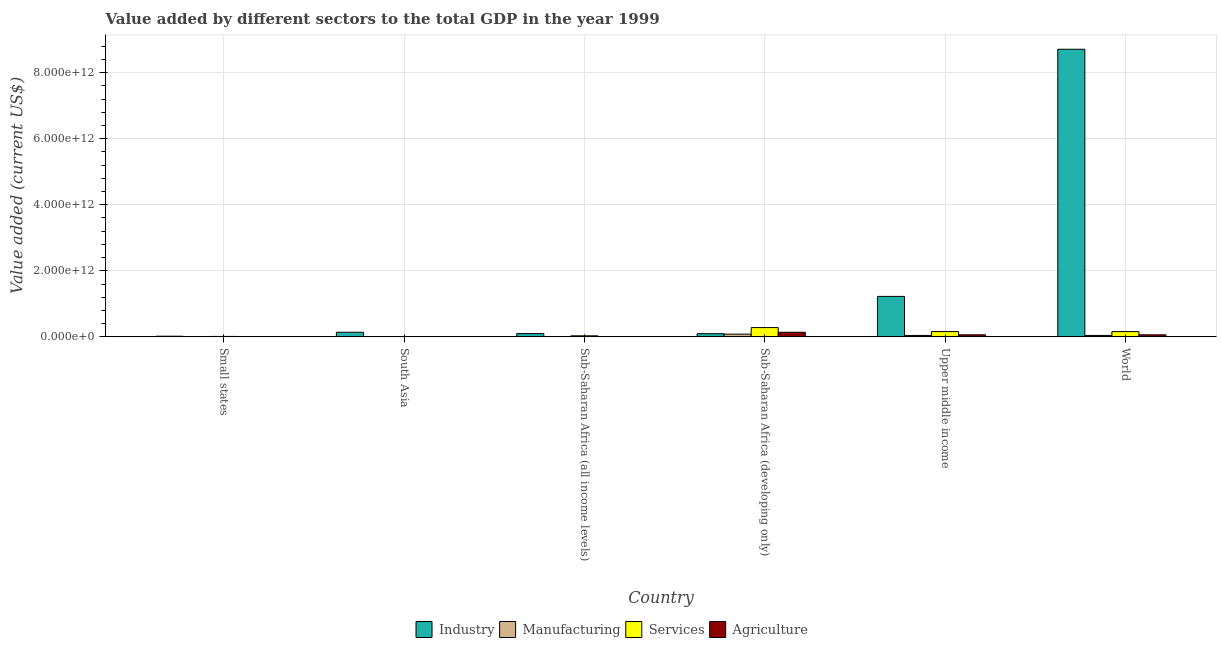How many different coloured bars are there?
Make the answer very short. 4. How many groups of bars are there?
Make the answer very short. 6. Are the number of bars per tick equal to the number of legend labels?
Your answer should be very brief. Yes. How many bars are there on the 6th tick from the left?
Your answer should be compact. 4. How many bars are there on the 6th tick from the right?
Provide a short and direct response. 4. What is the label of the 1st group of bars from the left?
Keep it short and to the point. Small states. What is the value added by industrial sector in South Asia?
Your response must be concise. 1.39e+11. Across all countries, what is the maximum value added by manufacturing sector?
Provide a succinct answer. 8.26e+1. Across all countries, what is the minimum value added by manufacturing sector?
Give a very brief answer. 3.54e+08. In which country was the value added by agricultural sector maximum?
Your answer should be very brief. Sub-Saharan Africa (developing only). In which country was the value added by services sector minimum?
Ensure brevity in your answer.  South Asia. What is the total value added by agricultural sector in the graph?
Your response must be concise. 2.71e+11. What is the difference between the value added by agricultural sector in Small states and that in South Asia?
Your answer should be very brief. 1.72e+09. What is the difference between the value added by services sector in Upper middle income and the value added by industrial sector in South Asia?
Ensure brevity in your answer.  2.04e+1. What is the average value added by industrial sector per country?
Make the answer very short. 1.72e+12. What is the difference between the value added by industrial sector and value added by services sector in Small states?
Your answer should be very brief. 6.79e+09. In how many countries, is the value added by industrial sector greater than 5200000000000 US$?
Provide a short and direct response. 1. What is the ratio of the value added by agricultural sector in Sub-Saharan Africa (all income levels) to that in Sub-Saharan Africa (developing only)?
Your answer should be very brief. 0.03. What is the difference between the highest and the second highest value added by manufacturing sector?
Offer a very short reply. 3.92e+1. What is the difference between the highest and the lowest value added by agricultural sector?
Provide a short and direct response. 1.38e+11. In how many countries, is the value added by industrial sector greater than the average value added by industrial sector taken over all countries?
Ensure brevity in your answer.  1. Is the sum of the value added by industrial sector in Small states and Sub-Saharan Africa (developing only) greater than the maximum value added by services sector across all countries?
Keep it short and to the point. No. Is it the case that in every country, the sum of the value added by agricultural sector and value added by services sector is greater than the sum of value added by industrial sector and value added by manufacturing sector?
Provide a succinct answer. No. What does the 2nd bar from the left in Small states represents?
Provide a short and direct response. Manufacturing. What does the 4th bar from the right in Sub-Saharan Africa (all income levels) represents?
Offer a terse response. Industry. How many bars are there?
Provide a short and direct response. 24. How many countries are there in the graph?
Offer a terse response. 6. What is the difference between two consecutive major ticks on the Y-axis?
Give a very brief answer. 2.00e+12. Are the values on the major ticks of Y-axis written in scientific E-notation?
Ensure brevity in your answer.  Yes. Does the graph contain grids?
Provide a short and direct response. Yes. How many legend labels are there?
Your response must be concise. 4. What is the title of the graph?
Offer a very short reply. Value added by different sectors to the total GDP in the year 1999. Does "Others" appear as one of the legend labels in the graph?
Offer a very short reply. No. What is the label or title of the Y-axis?
Ensure brevity in your answer.  Value added (current US$). What is the Value added (current US$) in Industry in Small states?
Your answer should be very brief. 2.01e+1. What is the Value added (current US$) of Manufacturing in Small states?
Ensure brevity in your answer.  3.18e+09. What is the Value added (current US$) of Services in Small states?
Your response must be concise. 1.33e+1. What is the Value added (current US$) in Agriculture in Small states?
Offer a very short reply. 2.44e+09. What is the Value added (current US$) of Industry in South Asia?
Give a very brief answer. 1.39e+11. What is the Value added (current US$) in Manufacturing in South Asia?
Ensure brevity in your answer.  3.54e+08. What is the Value added (current US$) of Services in South Asia?
Offer a very short reply. 1.94e+09. What is the Value added (current US$) in Agriculture in South Asia?
Your answer should be very brief. 7.24e+08. What is the Value added (current US$) of Industry in Sub-Saharan Africa (all income levels)?
Offer a very short reply. 9.94e+1. What is the Value added (current US$) in Manufacturing in Sub-Saharan Africa (all income levels)?
Your answer should be very brief. 5.74e+09. What is the Value added (current US$) in Services in Sub-Saharan Africa (all income levels)?
Offer a very short reply. 3.25e+1. What is the Value added (current US$) of Agriculture in Sub-Saharan Africa (all income levels)?
Offer a very short reply. 4.70e+09. What is the Value added (current US$) in Industry in Sub-Saharan Africa (developing only)?
Provide a short and direct response. 9.56e+1. What is the Value added (current US$) of Manufacturing in Sub-Saharan Africa (developing only)?
Give a very brief answer. 8.26e+1. What is the Value added (current US$) in Services in Sub-Saharan Africa (developing only)?
Give a very brief answer. 2.81e+11. What is the Value added (current US$) in Agriculture in Sub-Saharan Africa (developing only)?
Provide a short and direct response. 1.39e+11. What is the Value added (current US$) in Industry in Upper middle income?
Keep it short and to the point. 1.23e+12. What is the Value added (current US$) of Manufacturing in Upper middle income?
Provide a succinct answer. 4.34e+1. What is the Value added (current US$) in Services in Upper middle income?
Your answer should be very brief. 1.60e+11. What is the Value added (current US$) in Agriculture in Upper middle income?
Offer a terse response. 6.19e+1. What is the Value added (current US$) in Industry in World?
Give a very brief answer. 8.71e+12. What is the Value added (current US$) of Manufacturing in World?
Your response must be concise. 4.30e+1. What is the Value added (current US$) in Services in World?
Your answer should be very brief. 1.59e+11. What is the Value added (current US$) of Agriculture in World?
Offer a very short reply. 6.18e+1. Across all countries, what is the maximum Value added (current US$) in Industry?
Offer a very short reply. 8.71e+12. Across all countries, what is the maximum Value added (current US$) of Manufacturing?
Offer a very short reply. 8.26e+1. Across all countries, what is the maximum Value added (current US$) of Services?
Your answer should be compact. 2.81e+11. Across all countries, what is the maximum Value added (current US$) of Agriculture?
Your answer should be very brief. 1.39e+11. Across all countries, what is the minimum Value added (current US$) of Industry?
Your response must be concise. 2.01e+1. Across all countries, what is the minimum Value added (current US$) in Manufacturing?
Keep it short and to the point. 3.54e+08. Across all countries, what is the minimum Value added (current US$) of Services?
Ensure brevity in your answer.  1.94e+09. Across all countries, what is the minimum Value added (current US$) of Agriculture?
Provide a succinct answer. 7.24e+08. What is the total Value added (current US$) of Industry in the graph?
Your answer should be very brief. 1.03e+13. What is the total Value added (current US$) of Manufacturing in the graph?
Your answer should be compact. 1.78e+11. What is the total Value added (current US$) of Services in the graph?
Provide a succinct answer. 6.48e+11. What is the total Value added (current US$) in Agriculture in the graph?
Offer a very short reply. 2.71e+11. What is the difference between the Value added (current US$) in Industry in Small states and that in South Asia?
Make the answer very short. -1.19e+11. What is the difference between the Value added (current US$) in Manufacturing in Small states and that in South Asia?
Your response must be concise. 2.83e+09. What is the difference between the Value added (current US$) of Services in Small states and that in South Asia?
Offer a terse response. 1.13e+1. What is the difference between the Value added (current US$) of Agriculture in Small states and that in South Asia?
Give a very brief answer. 1.72e+09. What is the difference between the Value added (current US$) of Industry in Small states and that in Sub-Saharan Africa (all income levels)?
Make the answer very short. -7.94e+1. What is the difference between the Value added (current US$) of Manufacturing in Small states and that in Sub-Saharan Africa (all income levels)?
Provide a succinct answer. -2.55e+09. What is the difference between the Value added (current US$) in Services in Small states and that in Sub-Saharan Africa (all income levels)?
Ensure brevity in your answer.  -1.92e+1. What is the difference between the Value added (current US$) of Agriculture in Small states and that in Sub-Saharan Africa (all income levels)?
Provide a succinct answer. -2.26e+09. What is the difference between the Value added (current US$) of Industry in Small states and that in Sub-Saharan Africa (developing only)?
Make the answer very short. -7.56e+1. What is the difference between the Value added (current US$) in Manufacturing in Small states and that in Sub-Saharan Africa (developing only)?
Keep it short and to the point. -7.94e+1. What is the difference between the Value added (current US$) of Services in Small states and that in Sub-Saharan Africa (developing only)?
Provide a succinct answer. -2.68e+11. What is the difference between the Value added (current US$) in Agriculture in Small states and that in Sub-Saharan Africa (developing only)?
Your answer should be compact. -1.37e+11. What is the difference between the Value added (current US$) in Industry in Small states and that in Upper middle income?
Offer a terse response. -1.21e+12. What is the difference between the Value added (current US$) in Manufacturing in Small states and that in Upper middle income?
Give a very brief answer. -4.02e+1. What is the difference between the Value added (current US$) in Services in Small states and that in Upper middle income?
Give a very brief answer. -1.47e+11. What is the difference between the Value added (current US$) in Agriculture in Small states and that in Upper middle income?
Offer a terse response. -5.95e+1. What is the difference between the Value added (current US$) of Industry in Small states and that in World?
Give a very brief answer. -8.69e+12. What is the difference between the Value added (current US$) of Manufacturing in Small states and that in World?
Offer a very short reply. -3.98e+1. What is the difference between the Value added (current US$) of Services in Small states and that in World?
Offer a terse response. -1.46e+11. What is the difference between the Value added (current US$) in Agriculture in Small states and that in World?
Give a very brief answer. -5.94e+1. What is the difference between the Value added (current US$) in Industry in South Asia and that in Sub-Saharan Africa (all income levels)?
Offer a terse response. 4.01e+1. What is the difference between the Value added (current US$) in Manufacturing in South Asia and that in Sub-Saharan Africa (all income levels)?
Provide a short and direct response. -5.38e+09. What is the difference between the Value added (current US$) of Services in South Asia and that in Sub-Saharan Africa (all income levels)?
Keep it short and to the point. -3.06e+1. What is the difference between the Value added (current US$) in Agriculture in South Asia and that in Sub-Saharan Africa (all income levels)?
Your answer should be compact. -3.98e+09. What is the difference between the Value added (current US$) in Industry in South Asia and that in Sub-Saharan Africa (developing only)?
Offer a terse response. 4.38e+1. What is the difference between the Value added (current US$) in Manufacturing in South Asia and that in Sub-Saharan Africa (developing only)?
Your answer should be very brief. -8.22e+1. What is the difference between the Value added (current US$) in Services in South Asia and that in Sub-Saharan Africa (developing only)?
Your response must be concise. -2.79e+11. What is the difference between the Value added (current US$) of Agriculture in South Asia and that in Sub-Saharan Africa (developing only)?
Ensure brevity in your answer.  -1.38e+11. What is the difference between the Value added (current US$) in Industry in South Asia and that in Upper middle income?
Provide a short and direct response. -1.09e+12. What is the difference between the Value added (current US$) in Manufacturing in South Asia and that in Upper middle income?
Offer a very short reply. -4.30e+1. What is the difference between the Value added (current US$) of Services in South Asia and that in Upper middle income?
Offer a terse response. -1.58e+11. What is the difference between the Value added (current US$) in Agriculture in South Asia and that in Upper middle income?
Give a very brief answer. -6.12e+1. What is the difference between the Value added (current US$) of Industry in South Asia and that in World?
Make the answer very short. -8.57e+12. What is the difference between the Value added (current US$) in Manufacturing in South Asia and that in World?
Offer a terse response. -4.26e+1. What is the difference between the Value added (current US$) of Services in South Asia and that in World?
Your response must be concise. -1.57e+11. What is the difference between the Value added (current US$) in Agriculture in South Asia and that in World?
Keep it short and to the point. -6.11e+1. What is the difference between the Value added (current US$) of Industry in Sub-Saharan Africa (all income levels) and that in Sub-Saharan Africa (developing only)?
Offer a terse response. 3.78e+09. What is the difference between the Value added (current US$) in Manufacturing in Sub-Saharan Africa (all income levels) and that in Sub-Saharan Africa (developing only)?
Keep it short and to the point. -7.68e+1. What is the difference between the Value added (current US$) of Services in Sub-Saharan Africa (all income levels) and that in Sub-Saharan Africa (developing only)?
Your response must be concise. -2.49e+11. What is the difference between the Value added (current US$) of Agriculture in Sub-Saharan Africa (all income levels) and that in Sub-Saharan Africa (developing only)?
Ensure brevity in your answer.  -1.34e+11. What is the difference between the Value added (current US$) of Industry in Sub-Saharan Africa (all income levels) and that in Upper middle income?
Your answer should be very brief. -1.13e+12. What is the difference between the Value added (current US$) in Manufacturing in Sub-Saharan Africa (all income levels) and that in Upper middle income?
Ensure brevity in your answer.  -3.76e+1. What is the difference between the Value added (current US$) of Services in Sub-Saharan Africa (all income levels) and that in Upper middle income?
Ensure brevity in your answer.  -1.27e+11. What is the difference between the Value added (current US$) in Agriculture in Sub-Saharan Africa (all income levels) and that in Upper middle income?
Provide a short and direct response. -5.72e+1. What is the difference between the Value added (current US$) of Industry in Sub-Saharan Africa (all income levels) and that in World?
Give a very brief answer. -8.61e+12. What is the difference between the Value added (current US$) of Manufacturing in Sub-Saharan Africa (all income levels) and that in World?
Provide a short and direct response. -3.72e+1. What is the difference between the Value added (current US$) of Services in Sub-Saharan Africa (all income levels) and that in World?
Make the answer very short. -1.27e+11. What is the difference between the Value added (current US$) in Agriculture in Sub-Saharan Africa (all income levels) and that in World?
Your answer should be very brief. -5.71e+1. What is the difference between the Value added (current US$) in Industry in Sub-Saharan Africa (developing only) and that in Upper middle income?
Provide a succinct answer. -1.13e+12. What is the difference between the Value added (current US$) in Manufacturing in Sub-Saharan Africa (developing only) and that in Upper middle income?
Provide a succinct answer. 3.92e+1. What is the difference between the Value added (current US$) of Services in Sub-Saharan Africa (developing only) and that in Upper middle income?
Give a very brief answer. 1.21e+11. What is the difference between the Value added (current US$) in Agriculture in Sub-Saharan Africa (developing only) and that in Upper middle income?
Keep it short and to the point. 7.72e+1. What is the difference between the Value added (current US$) of Industry in Sub-Saharan Africa (developing only) and that in World?
Give a very brief answer. -8.61e+12. What is the difference between the Value added (current US$) in Manufacturing in Sub-Saharan Africa (developing only) and that in World?
Provide a short and direct response. 3.96e+1. What is the difference between the Value added (current US$) of Services in Sub-Saharan Africa (developing only) and that in World?
Keep it short and to the point. 1.22e+11. What is the difference between the Value added (current US$) in Agriculture in Sub-Saharan Africa (developing only) and that in World?
Give a very brief answer. 7.74e+1. What is the difference between the Value added (current US$) in Industry in Upper middle income and that in World?
Give a very brief answer. -7.48e+12. What is the difference between the Value added (current US$) in Manufacturing in Upper middle income and that in World?
Make the answer very short. 4.04e+08. What is the difference between the Value added (current US$) in Services in Upper middle income and that in World?
Your answer should be compact. 5.71e+08. What is the difference between the Value added (current US$) of Agriculture in Upper middle income and that in World?
Your response must be concise. 1.41e+08. What is the difference between the Value added (current US$) in Industry in Small states and the Value added (current US$) in Manufacturing in South Asia?
Offer a terse response. 1.97e+1. What is the difference between the Value added (current US$) in Industry in Small states and the Value added (current US$) in Services in South Asia?
Provide a short and direct response. 1.81e+1. What is the difference between the Value added (current US$) in Industry in Small states and the Value added (current US$) in Agriculture in South Asia?
Your answer should be very brief. 1.93e+1. What is the difference between the Value added (current US$) in Manufacturing in Small states and the Value added (current US$) in Services in South Asia?
Offer a terse response. 1.25e+09. What is the difference between the Value added (current US$) of Manufacturing in Small states and the Value added (current US$) of Agriculture in South Asia?
Your answer should be compact. 2.46e+09. What is the difference between the Value added (current US$) in Services in Small states and the Value added (current US$) in Agriculture in South Asia?
Keep it short and to the point. 1.25e+1. What is the difference between the Value added (current US$) of Industry in Small states and the Value added (current US$) of Manufacturing in Sub-Saharan Africa (all income levels)?
Keep it short and to the point. 1.43e+1. What is the difference between the Value added (current US$) of Industry in Small states and the Value added (current US$) of Services in Sub-Saharan Africa (all income levels)?
Provide a short and direct response. -1.24e+1. What is the difference between the Value added (current US$) of Industry in Small states and the Value added (current US$) of Agriculture in Sub-Saharan Africa (all income levels)?
Make the answer very short. 1.54e+1. What is the difference between the Value added (current US$) of Manufacturing in Small states and the Value added (current US$) of Services in Sub-Saharan Africa (all income levels)?
Give a very brief answer. -2.93e+1. What is the difference between the Value added (current US$) in Manufacturing in Small states and the Value added (current US$) in Agriculture in Sub-Saharan Africa (all income levels)?
Your answer should be compact. -1.52e+09. What is the difference between the Value added (current US$) of Services in Small states and the Value added (current US$) of Agriculture in Sub-Saharan Africa (all income levels)?
Your answer should be compact. 8.56e+09. What is the difference between the Value added (current US$) of Industry in Small states and the Value added (current US$) of Manufacturing in Sub-Saharan Africa (developing only)?
Provide a succinct answer. -6.25e+1. What is the difference between the Value added (current US$) in Industry in Small states and the Value added (current US$) in Services in Sub-Saharan Africa (developing only)?
Your answer should be very brief. -2.61e+11. What is the difference between the Value added (current US$) of Industry in Small states and the Value added (current US$) of Agriculture in Sub-Saharan Africa (developing only)?
Your response must be concise. -1.19e+11. What is the difference between the Value added (current US$) of Manufacturing in Small states and the Value added (current US$) of Services in Sub-Saharan Africa (developing only)?
Offer a very short reply. -2.78e+11. What is the difference between the Value added (current US$) of Manufacturing in Small states and the Value added (current US$) of Agriculture in Sub-Saharan Africa (developing only)?
Your response must be concise. -1.36e+11. What is the difference between the Value added (current US$) of Services in Small states and the Value added (current US$) of Agriculture in Sub-Saharan Africa (developing only)?
Provide a succinct answer. -1.26e+11. What is the difference between the Value added (current US$) of Industry in Small states and the Value added (current US$) of Manufacturing in Upper middle income?
Ensure brevity in your answer.  -2.33e+1. What is the difference between the Value added (current US$) in Industry in Small states and the Value added (current US$) in Services in Upper middle income?
Your response must be concise. -1.40e+11. What is the difference between the Value added (current US$) of Industry in Small states and the Value added (current US$) of Agriculture in Upper middle income?
Give a very brief answer. -4.19e+1. What is the difference between the Value added (current US$) in Manufacturing in Small states and the Value added (current US$) in Services in Upper middle income?
Ensure brevity in your answer.  -1.57e+11. What is the difference between the Value added (current US$) of Manufacturing in Small states and the Value added (current US$) of Agriculture in Upper middle income?
Offer a terse response. -5.88e+1. What is the difference between the Value added (current US$) of Services in Small states and the Value added (current US$) of Agriculture in Upper middle income?
Ensure brevity in your answer.  -4.87e+1. What is the difference between the Value added (current US$) of Industry in Small states and the Value added (current US$) of Manufacturing in World?
Your response must be concise. -2.29e+1. What is the difference between the Value added (current US$) of Industry in Small states and the Value added (current US$) of Services in World?
Provide a short and direct response. -1.39e+11. What is the difference between the Value added (current US$) of Industry in Small states and the Value added (current US$) of Agriculture in World?
Provide a short and direct response. -4.18e+1. What is the difference between the Value added (current US$) in Manufacturing in Small states and the Value added (current US$) in Services in World?
Offer a very short reply. -1.56e+11. What is the difference between the Value added (current US$) in Manufacturing in Small states and the Value added (current US$) in Agriculture in World?
Provide a succinct answer. -5.86e+1. What is the difference between the Value added (current US$) in Services in Small states and the Value added (current US$) in Agriculture in World?
Make the answer very short. -4.85e+1. What is the difference between the Value added (current US$) of Industry in South Asia and the Value added (current US$) of Manufacturing in Sub-Saharan Africa (all income levels)?
Your answer should be very brief. 1.34e+11. What is the difference between the Value added (current US$) in Industry in South Asia and the Value added (current US$) in Services in Sub-Saharan Africa (all income levels)?
Offer a very short reply. 1.07e+11. What is the difference between the Value added (current US$) of Industry in South Asia and the Value added (current US$) of Agriculture in Sub-Saharan Africa (all income levels)?
Your response must be concise. 1.35e+11. What is the difference between the Value added (current US$) of Manufacturing in South Asia and the Value added (current US$) of Services in Sub-Saharan Africa (all income levels)?
Give a very brief answer. -3.21e+1. What is the difference between the Value added (current US$) of Manufacturing in South Asia and the Value added (current US$) of Agriculture in Sub-Saharan Africa (all income levels)?
Your answer should be very brief. -4.35e+09. What is the difference between the Value added (current US$) in Services in South Asia and the Value added (current US$) in Agriculture in Sub-Saharan Africa (all income levels)?
Your answer should be compact. -2.77e+09. What is the difference between the Value added (current US$) of Industry in South Asia and the Value added (current US$) of Manufacturing in Sub-Saharan Africa (developing only)?
Provide a succinct answer. 5.69e+1. What is the difference between the Value added (current US$) in Industry in South Asia and the Value added (current US$) in Services in Sub-Saharan Africa (developing only)?
Provide a short and direct response. -1.42e+11. What is the difference between the Value added (current US$) in Industry in South Asia and the Value added (current US$) in Agriculture in Sub-Saharan Africa (developing only)?
Provide a short and direct response. 3.01e+08. What is the difference between the Value added (current US$) of Manufacturing in South Asia and the Value added (current US$) of Services in Sub-Saharan Africa (developing only)?
Give a very brief answer. -2.81e+11. What is the difference between the Value added (current US$) in Manufacturing in South Asia and the Value added (current US$) in Agriculture in Sub-Saharan Africa (developing only)?
Give a very brief answer. -1.39e+11. What is the difference between the Value added (current US$) of Services in South Asia and the Value added (current US$) of Agriculture in Sub-Saharan Africa (developing only)?
Your answer should be compact. -1.37e+11. What is the difference between the Value added (current US$) of Industry in South Asia and the Value added (current US$) of Manufacturing in Upper middle income?
Provide a short and direct response. 9.61e+1. What is the difference between the Value added (current US$) of Industry in South Asia and the Value added (current US$) of Services in Upper middle income?
Your answer should be compact. -2.04e+1. What is the difference between the Value added (current US$) of Industry in South Asia and the Value added (current US$) of Agriculture in Upper middle income?
Keep it short and to the point. 7.75e+1. What is the difference between the Value added (current US$) of Manufacturing in South Asia and the Value added (current US$) of Services in Upper middle income?
Offer a very short reply. -1.60e+11. What is the difference between the Value added (current US$) in Manufacturing in South Asia and the Value added (current US$) in Agriculture in Upper middle income?
Give a very brief answer. -6.16e+1. What is the difference between the Value added (current US$) of Services in South Asia and the Value added (current US$) of Agriculture in Upper middle income?
Your answer should be very brief. -6.00e+1. What is the difference between the Value added (current US$) of Industry in South Asia and the Value added (current US$) of Manufacturing in World?
Offer a terse response. 9.65e+1. What is the difference between the Value added (current US$) of Industry in South Asia and the Value added (current US$) of Services in World?
Your response must be concise. -1.98e+1. What is the difference between the Value added (current US$) in Industry in South Asia and the Value added (current US$) in Agriculture in World?
Give a very brief answer. 7.77e+1. What is the difference between the Value added (current US$) in Manufacturing in South Asia and the Value added (current US$) in Services in World?
Make the answer very short. -1.59e+11. What is the difference between the Value added (current US$) in Manufacturing in South Asia and the Value added (current US$) in Agriculture in World?
Your response must be concise. -6.15e+1. What is the difference between the Value added (current US$) in Services in South Asia and the Value added (current US$) in Agriculture in World?
Provide a short and direct response. -5.99e+1. What is the difference between the Value added (current US$) in Industry in Sub-Saharan Africa (all income levels) and the Value added (current US$) in Manufacturing in Sub-Saharan Africa (developing only)?
Make the answer very short. 1.69e+1. What is the difference between the Value added (current US$) in Industry in Sub-Saharan Africa (all income levels) and the Value added (current US$) in Services in Sub-Saharan Africa (developing only)?
Your response must be concise. -1.82e+11. What is the difference between the Value added (current US$) of Industry in Sub-Saharan Africa (all income levels) and the Value added (current US$) of Agriculture in Sub-Saharan Africa (developing only)?
Your answer should be very brief. -3.98e+1. What is the difference between the Value added (current US$) in Manufacturing in Sub-Saharan Africa (all income levels) and the Value added (current US$) in Services in Sub-Saharan Africa (developing only)?
Offer a very short reply. -2.75e+11. What is the difference between the Value added (current US$) in Manufacturing in Sub-Saharan Africa (all income levels) and the Value added (current US$) in Agriculture in Sub-Saharan Africa (developing only)?
Your answer should be very brief. -1.33e+11. What is the difference between the Value added (current US$) of Services in Sub-Saharan Africa (all income levels) and the Value added (current US$) of Agriculture in Sub-Saharan Africa (developing only)?
Provide a succinct answer. -1.07e+11. What is the difference between the Value added (current US$) of Industry in Sub-Saharan Africa (all income levels) and the Value added (current US$) of Manufacturing in Upper middle income?
Your answer should be very brief. 5.61e+1. What is the difference between the Value added (current US$) of Industry in Sub-Saharan Africa (all income levels) and the Value added (current US$) of Services in Upper middle income?
Give a very brief answer. -6.04e+1. What is the difference between the Value added (current US$) in Industry in Sub-Saharan Africa (all income levels) and the Value added (current US$) in Agriculture in Upper middle income?
Your response must be concise. 3.75e+1. What is the difference between the Value added (current US$) of Manufacturing in Sub-Saharan Africa (all income levels) and the Value added (current US$) of Services in Upper middle income?
Offer a terse response. -1.54e+11. What is the difference between the Value added (current US$) of Manufacturing in Sub-Saharan Africa (all income levels) and the Value added (current US$) of Agriculture in Upper middle income?
Make the answer very short. -5.62e+1. What is the difference between the Value added (current US$) in Services in Sub-Saharan Africa (all income levels) and the Value added (current US$) in Agriculture in Upper middle income?
Your response must be concise. -2.94e+1. What is the difference between the Value added (current US$) of Industry in Sub-Saharan Africa (all income levels) and the Value added (current US$) of Manufacturing in World?
Your answer should be compact. 5.65e+1. What is the difference between the Value added (current US$) in Industry in Sub-Saharan Africa (all income levels) and the Value added (current US$) in Services in World?
Offer a very short reply. -5.99e+1. What is the difference between the Value added (current US$) of Industry in Sub-Saharan Africa (all income levels) and the Value added (current US$) of Agriculture in World?
Your answer should be very brief. 3.76e+1. What is the difference between the Value added (current US$) in Manufacturing in Sub-Saharan Africa (all income levels) and the Value added (current US$) in Services in World?
Your answer should be very brief. -1.54e+11. What is the difference between the Value added (current US$) in Manufacturing in Sub-Saharan Africa (all income levels) and the Value added (current US$) in Agriculture in World?
Your answer should be very brief. -5.61e+1. What is the difference between the Value added (current US$) of Services in Sub-Saharan Africa (all income levels) and the Value added (current US$) of Agriculture in World?
Your response must be concise. -2.93e+1. What is the difference between the Value added (current US$) in Industry in Sub-Saharan Africa (developing only) and the Value added (current US$) in Manufacturing in Upper middle income?
Your response must be concise. 5.23e+1. What is the difference between the Value added (current US$) in Industry in Sub-Saharan Africa (developing only) and the Value added (current US$) in Services in Upper middle income?
Make the answer very short. -6.42e+1. What is the difference between the Value added (current US$) of Industry in Sub-Saharan Africa (developing only) and the Value added (current US$) of Agriculture in Upper middle income?
Give a very brief answer. 3.37e+1. What is the difference between the Value added (current US$) of Manufacturing in Sub-Saharan Africa (developing only) and the Value added (current US$) of Services in Upper middle income?
Offer a very short reply. -7.73e+1. What is the difference between the Value added (current US$) of Manufacturing in Sub-Saharan Africa (developing only) and the Value added (current US$) of Agriculture in Upper middle income?
Provide a short and direct response. 2.06e+1. What is the difference between the Value added (current US$) of Services in Sub-Saharan Africa (developing only) and the Value added (current US$) of Agriculture in Upper middle income?
Give a very brief answer. 2.19e+11. What is the difference between the Value added (current US$) of Industry in Sub-Saharan Africa (developing only) and the Value added (current US$) of Manufacturing in World?
Offer a terse response. 5.27e+1. What is the difference between the Value added (current US$) of Industry in Sub-Saharan Africa (developing only) and the Value added (current US$) of Services in World?
Offer a very short reply. -6.37e+1. What is the difference between the Value added (current US$) of Industry in Sub-Saharan Africa (developing only) and the Value added (current US$) of Agriculture in World?
Provide a short and direct response. 3.38e+1. What is the difference between the Value added (current US$) of Manufacturing in Sub-Saharan Africa (developing only) and the Value added (current US$) of Services in World?
Offer a terse response. -7.67e+1. What is the difference between the Value added (current US$) in Manufacturing in Sub-Saharan Africa (developing only) and the Value added (current US$) in Agriculture in World?
Your answer should be compact. 2.07e+1. What is the difference between the Value added (current US$) in Services in Sub-Saharan Africa (developing only) and the Value added (current US$) in Agriculture in World?
Your answer should be very brief. 2.19e+11. What is the difference between the Value added (current US$) in Industry in Upper middle income and the Value added (current US$) in Manufacturing in World?
Keep it short and to the point. 1.18e+12. What is the difference between the Value added (current US$) in Industry in Upper middle income and the Value added (current US$) in Services in World?
Give a very brief answer. 1.07e+12. What is the difference between the Value added (current US$) of Industry in Upper middle income and the Value added (current US$) of Agriculture in World?
Ensure brevity in your answer.  1.16e+12. What is the difference between the Value added (current US$) of Manufacturing in Upper middle income and the Value added (current US$) of Services in World?
Your answer should be compact. -1.16e+11. What is the difference between the Value added (current US$) of Manufacturing in Upper middle income and the Value added (current US$) of Agriculture in World?
Your answer should be compact. -1.84e+1. What is the difference between the Value added (current US$) in Services in Upper middle income and the Value added (current US$) in Agriculture in World?
Ensure brevity in your answer.  9.81e+1. What is the average Value added (current US$) of Industry per country?
Make the answer very short. 1.72e+12. What is the average Value added (current US$) of Manufacturing per country?
Your response must be concise. 2.97e+1. What is the average Value added (current US$) of Services per country?
Your response must be concise. 1.08e+11. What is the average Value added (current US$) in Agriculture per country?
Your answer should be very brief. 4.51e+1. What is the difference between the Value added (current US$) of Industry and Value added (current US$) of Manufacturing in Small states?
Keep it short and to the point. 1.69e+1. What is the difference between the Value added (current US$) of Industry and Value added (current US$) of Services in Small states?
Offer a terse response. 6.79e+09. What is the difference between the Value added (current US$) in Industry and Value added (current US$) in Agriculture in Small states?
Provide a succinct answer. 1.76e+1. What is the difference between the Value added (current US$) of Manufacturing and Value added (current US$) of Services in Small states?
Give a very brief answer. -1.01e+1. What is the difference between the Value added (current US$) of Manufacturing and Value added (current US$) of Agriculture in Small states?
Ensure brevity in your answer.  7.44e+08. What is the difference between the Value added (current US$) of Services and Value added (current US$) of Agriculture in Small states?
Offer a very short reply. 1.08e+1. What is the difference between the Value added (current US$) of Industry and Value added (current US$) of Manufacturing in South Asia?
Give a very brief answer. 1.39e+11. What is the difference between the Value added (current US$) in Industry and Value added (current US$) in Services in South Asia?
Provide a short and direct response. 1.38e+11. What is the difference between the Value added (current US$) of Industry and Value added (current US$) of Agriculture in South Asia?
Your answer should be compact. 1.39e+11. What is the difference between the Value added (current US$) in Manufacturing and Value added (current US$) in Services in South Asia?
Your answer should be very brief. -1.58e+09. What is the difference between the Value added (current US$) of Manufacturing and Value added (current US$) of Agriculture in South Asia?
Give a very brief answer. -3.71e+08. What is the difference between the Value added (current US$) in Services and Value added (current US$) in Agriculture in South Asia?
Offer a very short reply. 1.21e+09. What is the difference between the Value added (current US$) in Industry and Value added (current US$) in Manufacturing in Sub-Saharan Africa (all income levels)?
Offer a very short reply. 9.37e+1. What is the difference between the Value added (current US$) of Industry and Value added (current US$) of Services in Sub-Saharan Africa (all income levels)?
Give a very brief answer. 6.69e+1. What is the difference between the Value added (current US$) of Industry and Value added (current US$) of Agriculture in Sub-Saharan Africa (all income levels)?
Provide a succinct answer. 9.47e+1. What is the difference between the Value added (current US$) of Manufacturing and Value added (current US$) of Services in Sub-Saharan Africa (all income levels)?
Ensure brevity in your answer.  -2.68e+1. What is the difference between the Value added (current US$) in Manufacturing and Value added (current US$) in Agriculture in Sub-Saharan Africa (all income levels)?
Ensure brevity in your answer.  1.03e+09. What is the difference between the Value added (current US$) in Services and Value added (current US$) in Agriculture in Sub-Saharan Africa (all income levels)?
Make the answer very short. 2.78e+1. What is the difference between the Value added (current US$) of Industry and Value added (current US$) of Manufacturing in Sub-Saharan Africa (developing only)?
Make the answer very short. 1.31e+1. What is the difference between the Value added (current US$) in Industry and Value added (current US$) in Services in Sub-Saharan Africa (developing only)?
Keep it short and to the point. -1.85e+11. What is the difference between the Value added (current US$) in Industry and Value added (current US$) in Agriculture in Sub-Saharan Africa (developing only)?
Ensure brevity in your answer.  -4.35e+1. What is the difference between the Value added (current US$) of Manufacturing and Value added (current US$) of Services in Sub-Saharan Africa (developing only)?
Offer a very short reply. -1.99e+11. What is the difference between the Value added (current US$) in Manufacturing and Value added (current US$) in Agriculture in Sub-Saharan Africa (developing only)?
Provide a short and direct response. -5.66e+1. What is the difference between the Value added (current US$) in Services and Value added (current US$) in Agriculture in Sub-Saharan Africa (developing only)?
Ensure brevity in your answer.  1.42e+11. What is the difference between the Value added (current US$) in Industry and Value added (current US$) in Manufacturing in Upper middle income?
Your answer should be compact. 1.18e+12. What is the difference between the Value added (current US$) of Industry and Value added (current US$) of Services in Upper middle income?
Your response must be concise. 1.07e+12. What is the difference between the Value added (current US$) of Industry and Value added (current US$) of Agriculture in Upper middle income?
Make the answer very short. 1.16e+12. What is the difference between the Value added (current US$) of Manufacturing and Value added (current US$) of Services in Upper middle income?
Offer a very short reply. -1.17e+11. What is the difference between the Value added (current US$) of Manufacturing and Value added (current US$) of Agriculture in Upper middle income?
Your response must be concise. -1.86e+1. What is the difference between the Value added (current US$) of Services and Value added (current US$) of Agriculture in Upper middle income?
Provide a short and direct response. 9.79e+1. What is the difference between the Value added (current US$) of Industry and Value added (current US$) of Manufacturing in World?
Provide a succinct answer. 8.67e+12. What is the difference between the Value added (current US$) in Industry and Value added (current US$) in Services in World?
Your response must be concise. 8.55e+12. What is the difference between the Value added (current US$) of Industry and Value added (current US$) of Agriculture in World?
Ensure brevity in your answer.  8.65e+12. What is the difference between the Value added (current US$) in Manufacturing and Value added (current US$) in Services in World?
Make the answer very short. -1.16e+11. What is the difference between the Value added (current US$) in Manufacturing and Value added (current US$) in Agriculture in World?
Offer a very short reply. -1.88e+1. What is the difference between the Value added (current US$) of Services and Value added (current US$) of Agriculture in World?
Keep it short and to the point. 9.75e+1. What is the ratio of the Value added (current US$) of Industry in Small states to that in South Asia?
Offer a very short reply. 0.14. What is the ratio of the Value added (current US$) in Manufacturing in Small states to that in South Asia?
Offer a terse response. 9.01. What is the ratio of the Value added (current US$) of Services in Small states to that in South Asia?
Ensure brevity in your answer.  6.85. What is the ratio of the Value added (current US$) in Agriculture in Small states to that in South Asia?
Provide a short and direct response. 3.37. What is the ratio of the Value added (current US$) of Industry in Small states to that in Sub-Saharan Africa (all income levels)?
Offer a very short reply. 0.2. What is the ratio of the Value added (current US$) of Manufacturing in Small states to that in Sub-Saharan Africa (all income levels)?
Ensure brevity in your answer.  0.56. What is the ratio of the Value added (current US$) in Services in Small states to that in Sub-Saharan Africa (all income levels)?
Make the answer very short. 0.41. What is the ratio of the Value added (current US$) of Agriculture in Small states to that in Sub-Saharan Africa (all income levels)?
Provide a short and direct response. 0.52. What is the ratio of the Value added (current US$) in Industry in Small states to that in Sub-Saharan Africa (developing only)?
Your answer should be compact. 0.21. What is the ratio of the Value added (current US$) in Manufacturing in Small states to that in Sub-Saharan Africa (developing only)?
Your answer should be very brief. 0.04. What is the ratio of the Value added (current US$) of Services in Small states to that in Sub-Saharan Africa (developing only)?
Keep it short and to the point. 0.05. What is the ratio of the Value added (current US$) of Agriculture in Small states to that in Sub-Saharan Africa (developing only)?
Give a very brief answer. 0.02. What is the ratio of the Value added (current US$) in Industry in Small states to that in Upper middle income?
Provide a succinct answer. 0.02. What is the ratio of the Value added (current US$) of Manufacturing in Small states to that in Upper middle income?
Your answer should be very brief. 0.07. What is the ratio of the Value added (current US$) in Services in Small states to that in Upper middle income?
Your answer should be very brief. 0.08. What is the ratio of the Value added (current US$) in Agriculture in Small states to that in Upper middle income?
Your answer should be very brief. 0.04. What is the ratio of the Value added (current US$) of Industry in Small states to that in World?
Make the answer very short. 0. What is the ratio of the Value added (current US$) of Manufacturing in Small states to that in World?
Your response must be concise. 0.07. What is the ratio of the Value added (current US$) in Services in Small states to that in World?
Provide a short and direct response. 0.08. What is the ratio of the Value added (current US$) of Agriculture in Small states to that in World?
Your answer should be very brief. 0.04. What is the ratio of the Value added (current US$) of Industry in South Asia to that in Sub-Saharan Africa (all income levels)?
Keep it short and to the point. 1.4. What is the ratio of the Value added (current US$) of Manufacturing in South Asia to that in Sub-Saharan Africa (all income levels)?
Make the answer very short. 0.06. What is the ratio of the Value added (current US$) of Services in South Asia to that in Sub-Saharan Africa (all income levels)?
Your answer should be compact. 0.06. What is the ratio of the Value added (current US$) in Agriculture in South Asia to that in Sub-Saharan Africa (all income levels)?
Offer a terse response. 0.15. What is the ratio of the Value added (current US$) in Industry in South Asia to that in Sub-Saharan Africa (developing only)?
Your answer should be compact. 1.46. What is the ratio of the Value added (current US$) of Manufacturing in South Asia to that in Sub-Saharan Africa (developing only)?
Keep it short and to the point. 0. What is the ratio of the Value added (current US$) in Services in South Asia to that in Sub-Saharan Africa (developing only)?
Your answer should be very brief. 0.01. What is the ratio of the Value added (current US$) in Agriculture in South Asia to that in Sub-Saharan Africa (developing only)?
Provide a short and direct response. 0.01. What is the ratio of the Value added (current US$) in Industry in South Asia to that in Upper middle income?
Give a very brief answer. 0.11. What is the ratio of the Value added (current US$) in Manufacturing in South Asia to that in Upper middle income?
Offer a very short reply. 0.01. What is the ratio of the Value added (current US$) of Services in South Asia to that in Upper middle income?
Offer a very short reply. 0.01. What is the ratio of the Value added (current US$) of Agriculture in South Asia to that in Upper middle income?
Keep it short and to the point. 0.01. What is the ratio of the Value added (current US$) in Industry in South Asia to that in World?
Give a very brief answer. 0.02. What is the ratio of the Value added (current US$) in Manufacturing in South Asia to that in World?
Offer a very short reply. 0.01. What is the ratio of the Value added (current US$) in Services in South Asia to that in World?
Provide a succinct answer. 0.01. What is the ratio of the Value added (current US$) of Agriculture in South Asia to that in World?
Your response must be concise. 0.01. What is the ratio of the Value added (current US$) in Industry in Sub-Saharan Africa (all income levels) to that in Sub-Saharan Africa (developing only)?
Ensure brevity in your answer.  1.04. What is the ratio of the Value added (current US$) in Manufacturing in Sub-Saharan Africa (all income levels) to that in Sub-Saharan Africa (developing only)?
Provide a succinct answer. 0.07. What is the ratio of the Value added (current US$) in Services in Sub-Saharan Africa (all income levels) to that in Sub-Saharan Africa (developing only)?
Your answer should be compact. 0.12. What is the ratio of the Value added (current US$) in Agriculture in Sub-Saharan Africa (all income levels) to that in Sub-Saharan Africa (developing only)?
Provide a short and direct response. 0.03. What is the ratio of the Value added (current US$) in Industry in Sub-Saharan Africa (all income levels) to that in Upper middle income?
Make the answer very short. 0.08. What is the ratio of the Value added (current US$) of Manufacturing in Sub-Saharan Africa (all income levels) to that in Upper middle income?
Offer a terse response. 0.13. What is the ratio of the Value added (current US$) in Services in Sub-Saharan Africa (all income levels) to that in Upper middle income?
Ensure brevity in your answer.  0.2. What is the ratio of the Value added (current US$) in Agriculture in Sub-Saharan Africa (all income levels) to that in Upper middle income?
Provide a short and direct response. 0.08. What is the ratio of the Value added (current US$) in Industry in Sub-Saharan Africa (all income levels) to that in World?
Keep it short and to the point. 0.01. What is the ratio of the Value added (current US$) in Manufacturing in Sub-Saharan Africa (all income levels) to that in World?
Provide a short and direct response. 0.13. What is the ratio of the Value added (current US$) in Services in Sub-Saharan Africa (all income levels) to that in World?
Your response must be concise. 0.2. What is the ratio of the Value added (current US$) in Agriculture in Sub-Saharan Africa (all income levels) to that in World?
Provide a short and direct response. 0.08. What is the ratio of the Value added (current US$) of Industry in Sub-Saharan Africa (developing only) to that in Upper middle income?
Your answer should be compact. 0.08. What is the ratio of the Value added (current US$) in Manufacturing in Sub-Saharan Africa (developing only) to that in Upper middle income?
Your answer should be very brief. 1.9. What is the ratio of the Value added (current US$) in Services in Sub-Saharan Africa (developing only) to that in Upper middle income?
Your answer should be very brief. 1.76. What is the ratio of the Value added (current US$) in Agriculture in Sub-Saharan Africa (developing only) to that in Upper middle income?
Your answer should be compact. 2.25. What is the ratio of the Value added (current US$) of Industry in Sub-Saharan Africa (developing only) to that in World?
Keep it short and to the point. 0.01. What is the ratio of the Value added (current US$) of Manufacturing in Sub-Saharan Africa (developing only) to that in World?
Make the answer very short. 1.92. What is the ratio of the Value added (current US$) in Services in Sub-Saharan Africa (developing only) to that in World?
Offer a very short reply. 1.76. What is the ratio of the Value added (current US$) in Agriculture in Sub-Saharan Africa (developing only) to that in World?
Ensure brevity in your answer.  2.25. What is the ratio of the Value added (current US$) in Industry in Upper middle income to that in World?
Make the answer very short. 0.14. What is the ratio of the Value added (current US$) of Manufacturing in Upper middle income to that in World?
Ensure brevity in your answer.  1.01. What is the ratio of the Value added (current US$) in Services in Upper middle income to that in World?
Give a very brief answer. 1. What is the difference between the highest and the second highest Value added (current US$) of Industry?
Provide a succinct answer. 7.48e+12. What is the difference between the highest and the second highest Value added (current US$) of Manufacturing?
Keep it short and to the point. 3.92e+1. What is the difference between the highest and the second highest Value added (current US$) in Services?
Ensure brevity in your answer.  1.21e+11. What is the difference between the highest and the second highest Value added (current US$) of Agriculture?
Ensure brevity in your answer.  7.72e+1. What is the difference between the highest and the lowest Value added (current US$) in Industry?
Your response must be concise. 8.69e+12. What is the difference between the highest and the lowest Value added (current US$) of Manufacturing?
Offer a terse response. 8.22e+1. What is the difference between the highest and the lowest Value added (current US$) in Services?
Offer a very short reply. 2.79e+11. What is the difference between the highest and the lowest Value added (current US$) in Agriculture?
Provide a succinct answer. 1.38e+11. 